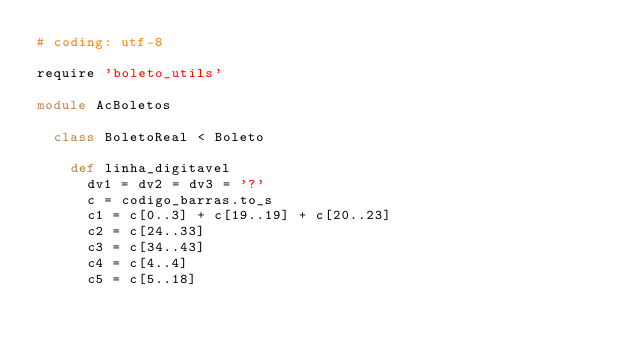Convert code to text. <code><loc_0><loc_0><loc_500><loc_500><_Ruby_># coding: utf-8

require 'boleto_utils'

module AcBoletos

  class BoletoReal < Boleto

    def linha_digitavel
      dv1 = dv2 = dv3 = '?'
      c = codigo_barras.to_s
      c1 = c[0..3] + c[19..19] + c[20..23]
      c2 = c[24..33]
      c3 = c[34..43]
      c4 = c[4..4]
      c5 = c[5..18]
</code> 